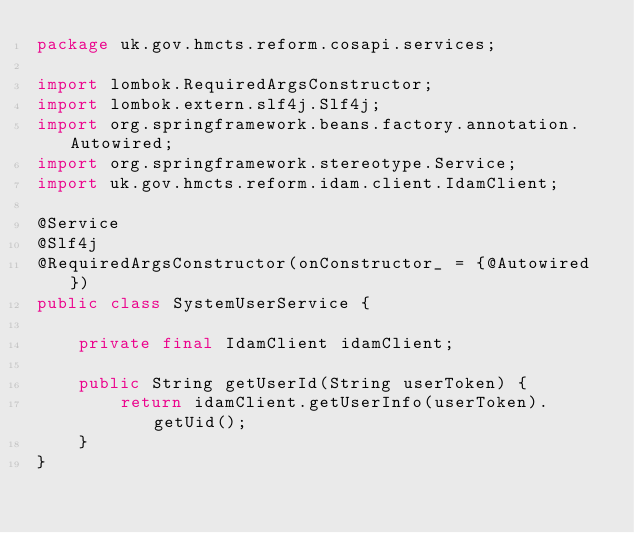Convert code to text. <code><loc_0><loc_0><loc_500><loc_500><_Java_>package uk.gov.hmcts.reform.cosapi.services;

import lombok.RequiredArgsConstructor;
import lombok.extern.slf4j.Slf4j;
import org.springframework.beans.factory.annotation.Autowired;
import org.springframework.stereotype.Service;
import uk.gov.hmcts.reform.idam.client.IdamClient;

@Service
@Slf4j
@RequiredArgsConstructor(onConstructor_ = {@Autowired})
public class SystemUserService {

    private final IdamClient idamClient;

    public String getUserId(String userToken) {
        return idamClient.getUserInfo(userToken).getUid();
    }
}
</code> 